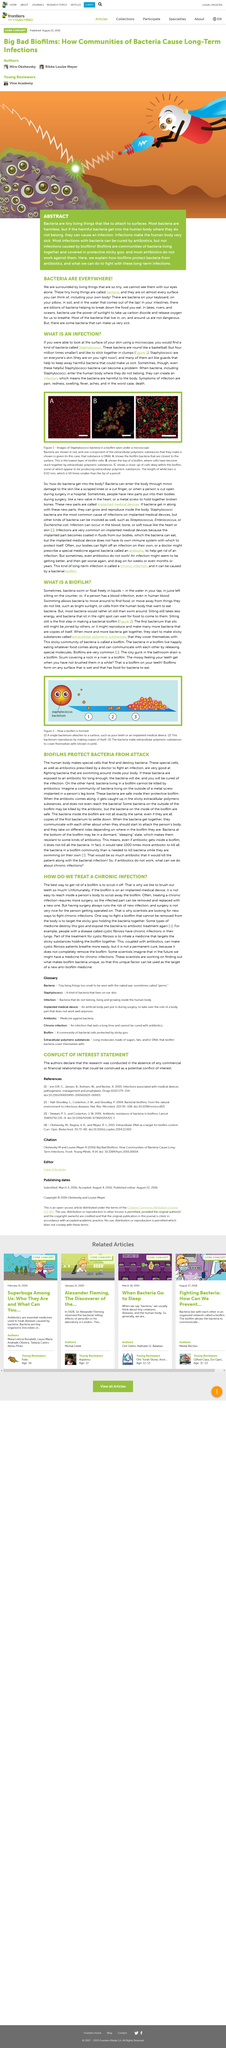Draw attention to some important aspects in this diagram. Bacteria move around in order to find food or avoid things they dislike, through a process called swimming. The most effective method for eliminating a biofilm is to physically scrub it away. Biofilms can be found on any wet and nutrient-rich surface, including medical devices, surfaces in healthcare facilities, and even on the skin. They are formed by a community of bacteria that secrete a slime-like substance to protect themselves and provide a favorable environment for growth and survival. These communities can cause a range of infections, including skin, urinary tract, and bloodstream infections, and can be difficult to treat due to their resistance to antibiotics. Scientists are seeking alternative methods to combat chronic infections due to the potential risks associated with surgical procedures, which can lead to further infections and negatively impact the person undergoing the operation. A biofilm is a sticky community of bacteria that forms on a surface and is characterized by its resistance to antibiotics and the immune system. 